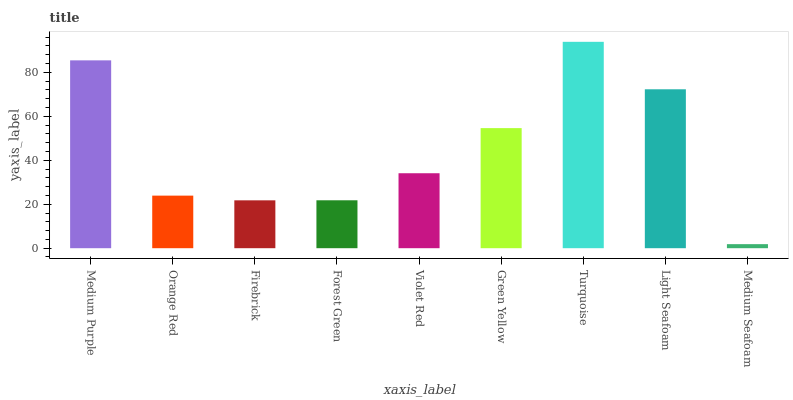Is Orange Red the minimum?
Answer yes or no. No. Is Orange Red the maximum?
Answer yes or no. No. Is Medium Purple greater than Orange Red?
Answer yes or no. Yes. Is Orange Red less than Medium Purple?
Answer yes or no. Yes. Is Orange Red greater than Medium Purple?
Answer yes or no. No. Is Medium Purple less than Orange Red?
Answer yes or no. No. Is Violet Red the high median?
Answer yes or no. Yes. Is Violet Red the low median?
Answer yes or no. Yes. Is Light Seafoam the high median?
Answer yes or no. No. Is Light Seafoam the low median?
Answer yes or no. No. 